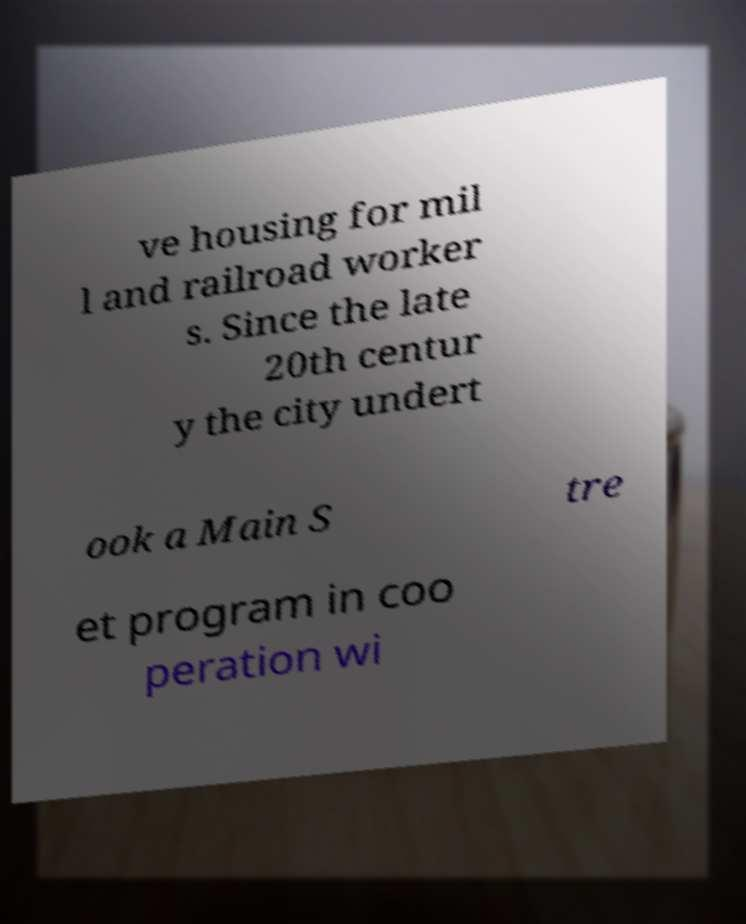Could you extract and type out the text from this image? ve housing for mil l and railroad worker s. Since the late 20th centur y the city undert ook a Main S tre et program in coo peration wi 